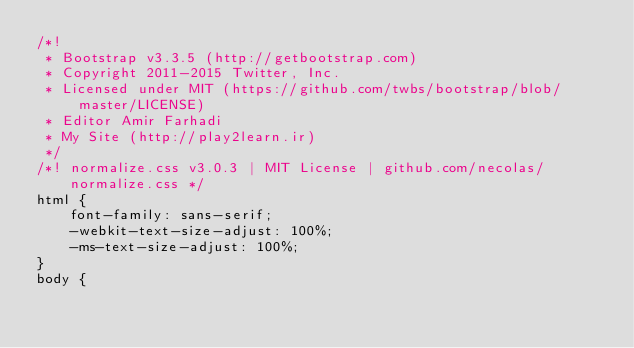Convert code to text. <code><loc_0><loc_0><loc_500><loc_500><_CSS_>/*!
 * Bootstrap v3.3.5 (http://getbootstrap.com)
 * Copyright 2011-2015 Twitter, Inc.
 * Licensed under MIT (https://github.com/twbs/bootstrap/blob/master/LICENSE)
 * Editor Amir Farhadi
 * My Site (http://play2learn.ir)
 */
/*! normalize.css v3.0.3 | MIT License | github.com/necolas/normalize.css */
html {
    font-family: sans-serif;
    -webkit-text-size-adjust: 100%;
    -ms-text-size-adjust: 100%;
}
body {</code> 